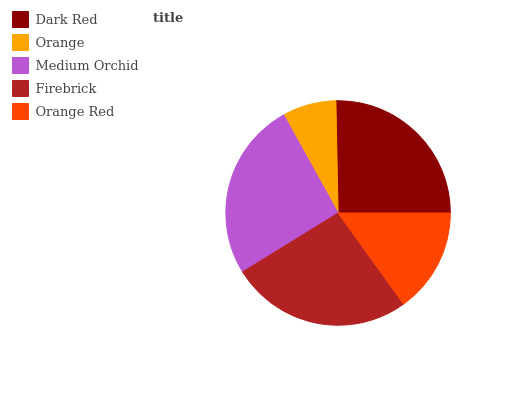Is Orange the minimum?
Answer yes or no. Yes. Is Firebrick the maximum?
Answer yes or no. Yes. Is Medium Orchid the minimum?
Answer yes or no. No. Is Medium Orchid the maximum?
Answer yes or no. No. Is Medium Orchid greater than Orange?
Answer yes or no. Yes. Is Orange less than Medium Orchid?
Answer yes or no. Yes. Is Orange greater than Medium Orchid?
Answer yes or no. No. Is Medium Orchid less than Orange?
Answer yes or no. No. Is Dark Red the high median?
Answer yes or no. Yes. Is Dark Red the low median?
Answer yes or no. Yes. Is Orange the high median?
Answer yes or no. No. Is Medium Orchid the low median?
Answer yes or no. No. 